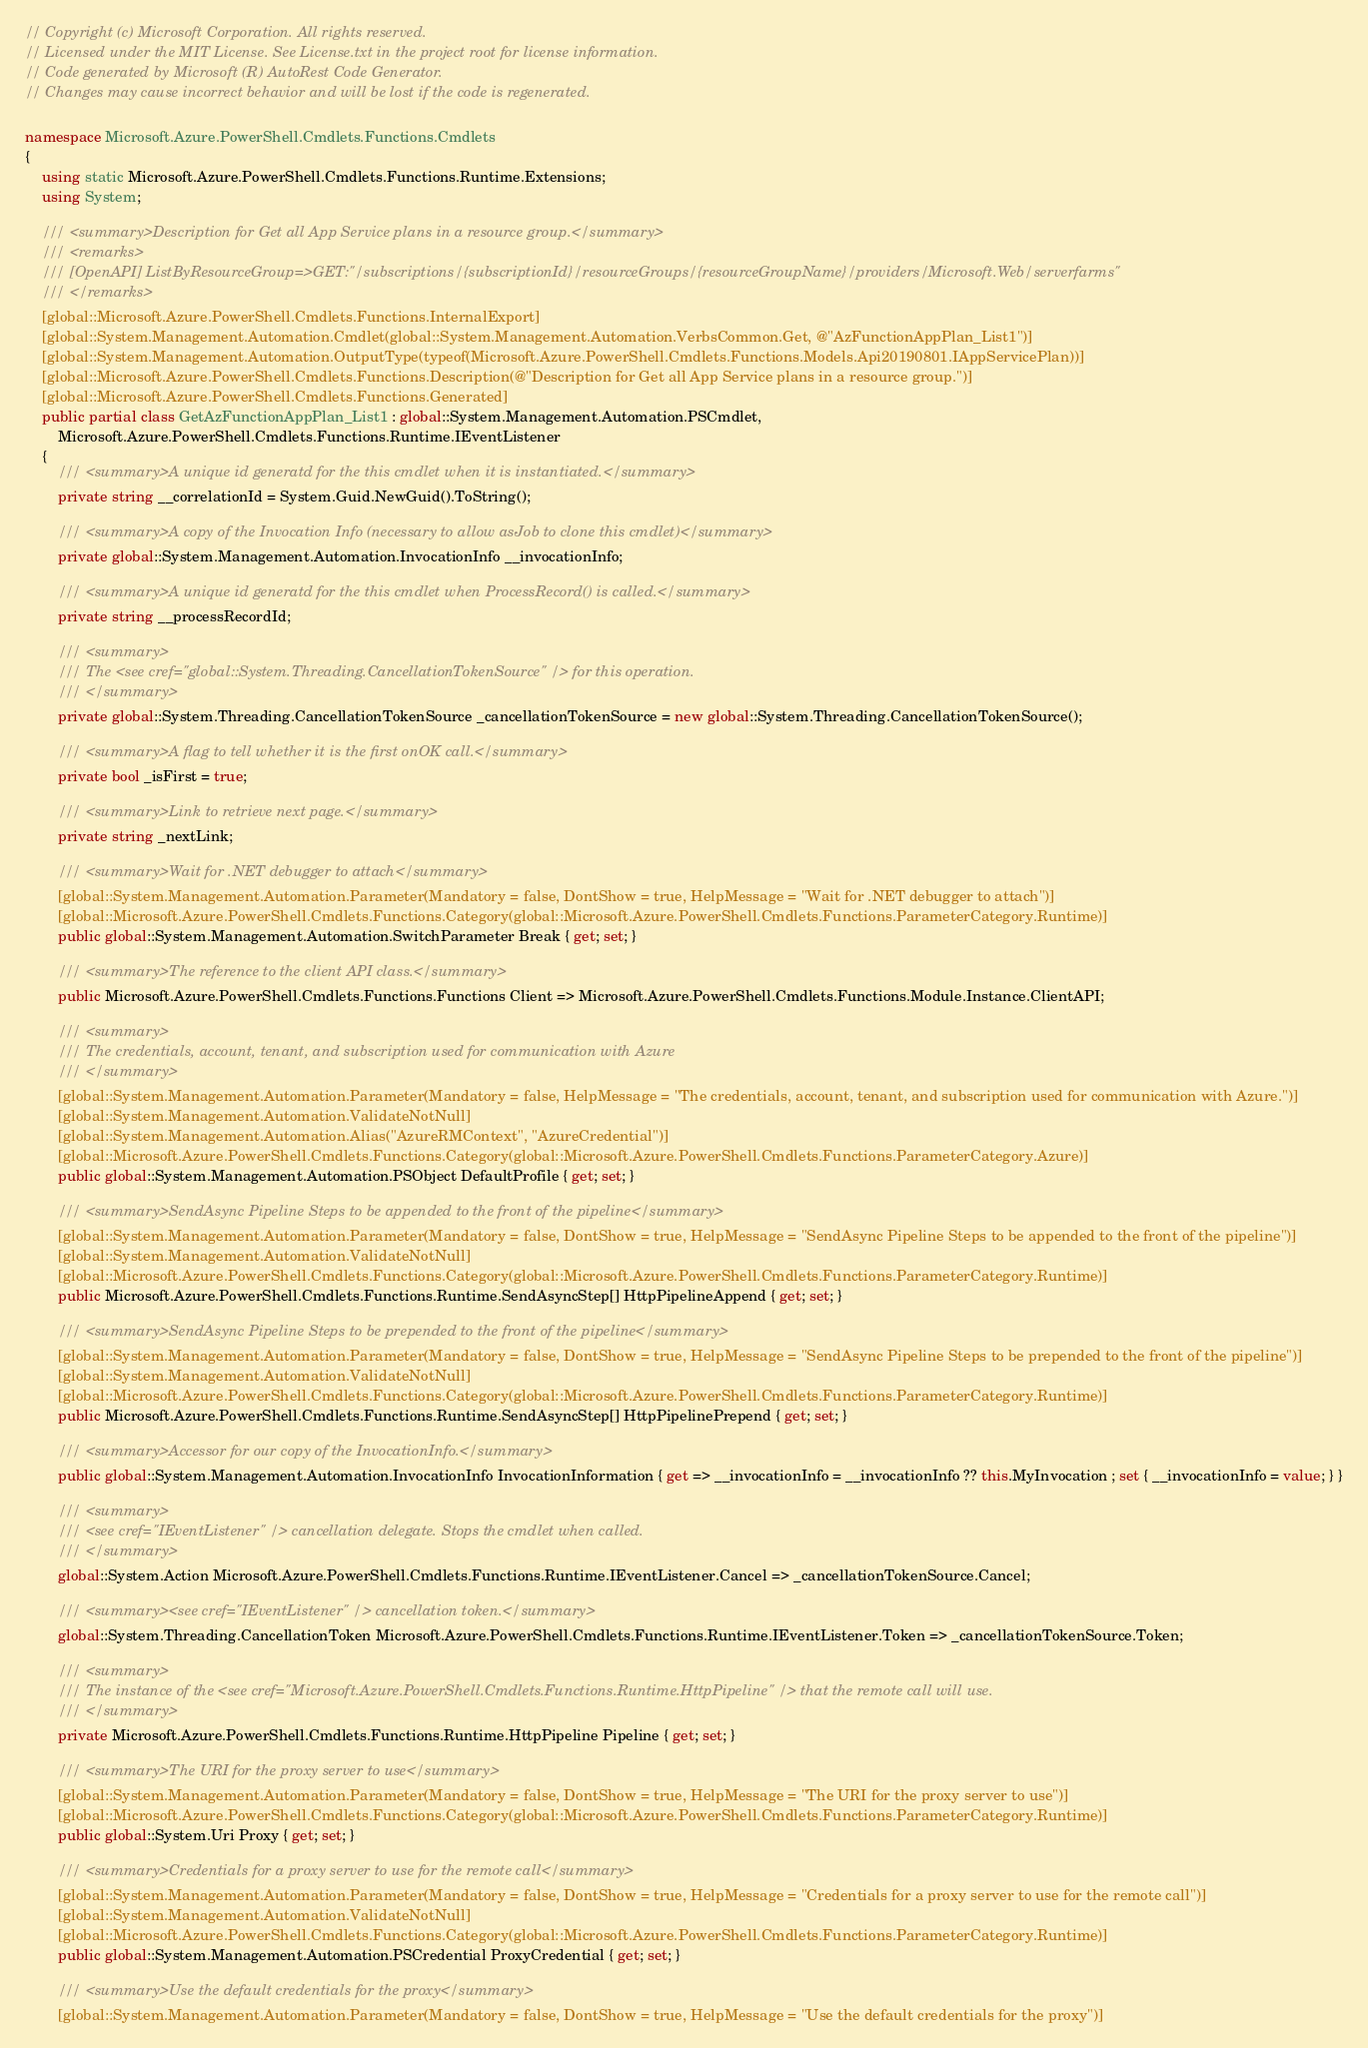<code> <loc_0><loc_0><loc_500><loc_500><_C#_>// Copyright (c) Microsoft Corporation. All rights reserved.
// Licensed under the MIT License. See License.txt in the project root for license information.
// Code generated by Microsoft (R) AutoRest Code Generator.
// Changes may cause incorrect behavior and will be lost if the code is regenerated.

namespace Microsoft.Azure.PowerShell.Cmdlets.Functions.Cmdlets
{
    using static Microsoft.Azure.PowerShell.Cmdlets.Functions.Runtime.Extensions;
    using System;

    /// <summary>Description for Get all App Service plans in a resource group.</summary>
    /// <remarks>
    /// [OpenAPI] ListByResourceGroup=>GET:"/subscriptions/{subscriptionId}/resourceGroups/{resourceGroupName}/providers/Microsoft.Web/serverfarms"
    /// </remarks>
    [global::Microsoft.Azure.PowerShell.Cmdlets.Functions.InternalExport]
    [global::System.Management.Automation.Cmdlet(global::System.Management.Automation.VerbsCommon.Get, @"AzFunctionAppPlan_List1")]
    [global::System.Management.Automation.OutputType(typeof(Microsoft.Azure.PowerShell.Cmdlets.Functions.Models.Api20190801.IAppServicePlan))]
    [global::Microsoft.Azure.PowerShell.Cmdlets.Functions.Description(@"Description for Get all App Service plans in a resource group.")]
    [global::Microsoft.Azure.PowerShell.Cmdlets.Functions.Generated]
    public partial class GetAzFunctionAppPlan_List1 : global::System.Management.Automation.PSCmdlet,
        Microsoft.Azure.PowerShell.Cmdlets.Functions.Runtime.IEventListener
    {
        /// <summary>A unique id generatd for the this cmdlet when it is instantiated.</summary>
        private string __correlationId = System.Guid.NewGuid().ToString();

        /// <summary>A copy of the Invocation Info (necessary to allow asJob to clone this cmdlet)</summary>
        private global::System.Management.Automation.InvocationInfo __invocationInfo;

        /// <summary>A unique id generatd for the this cmdlet when ProcessRecord() is called.</summary>
        private string __processRecordId;

        /// <summary>
        /// The <see cref="global::System.Threading.CancellationTokenSource" /> for this operation.
        /// </summary>
        private global::System.Threading.CancellationTokenSource _cancellationTokenSource = new global::System.Threading.CancellationTokenSource();

        /// <summary>A flag to tell whether it is the first onOK call.</summary>
        private bool _isFirst = true;

        /// <summary>Link to retrieve next page.</summary>
        private string _nextLink;

        /// <summary>Wait for .NET debugger to attach</summary>
        [global::System.Management.Automation.Parameter(Mandatory = false, DontShow = true, HelpMessage = "Wait for .NET debugger to attach")]
        [global::Microsoft.Azure.PowerShell.Cmdlets.Functions.Category(global::Microsoft.Azure.PowerShell.Cmdlets.Functions.ParameterCategory.Runtime)]
        public global::System.Management.Automation.SwitchParameter Break { get; set; }

        /// <summary>The reference to the client API class.</summary>
        public Microsoft.Azure.PowerShell.Cmdlets.Functions.Functions Client => Microsoft.Azure.PowerShell.Cmdlets.Functions.Module.Instance.ClientAPI;

        /// <summary>
        /// The credentials, account, tenant, and subscription used for communication with Azure
        /// </summary>
        [global::System.Management.Automation.Parameter(Mandatory = false, HelpMessage = "The credentials, account, tenant, and subscription used for communication with Azure.")]
        [global::System.Management.Automation.ValidateNotNull]
        [global::System.Management.Automation.Alias("AzureRMContext", "AzureCredential")]
        [global::Microsoft.Azure.PowerShell.Cmdlets.Functions.Category(global::Microsoft.Azure.PowerShell.Cmdlets.Functions.ParameterCategory.Azure)]
        public global::System.Management.Automation.PSObject DefaultProfile { get; set; }

        /// <summary>SendAsync Pipeline Steps to be appended to the front of the pipeline</summary>
        [global::System.Management.Automation.Parameter(Mandatory = false, DontShow = true, HelpMessage = "SendAsync Pipeline Steps to be appended to the front of the pipeline")]
        [global::System.Management.Automation.ValidateNotNull]
        [global::Microsoft.Azure.PowerShell.Cmdlets.Functions.Category(global::Microsoft.Azure.PowerShell.Cmdlets.Functions.ParameterCategory.Runtime)]
        public Microsoft.Azure.PowerShell.Cmdlets.Functions.Runtime.SendAsyncStep[] HttpPipelineAppend { get; set; }

        /// <summary>SendAsync Pipeline Steps to be prepended to the front of the pipeline</summary>
        [global::System.Management.Automation.Parameter(Mandatory = false, DontShow = true, HelpMessage = "SendAsync Pipeline Steps to be prepended to the front of the pipeline")]
        [global::System.Management.Automation.ValidateNotNull]
        [global::Microsoft.Azure.PowerShell.Cmdlets.Functions.Category(global::Microsoft.Azure.PowerShell.Cmdlets.Functions.ParameterCategory.Runtime)]
        public Microsoft.Azure.PowerShell.Cmdlets.Functions.Runtime.SendAsyncStep[] HttpPipelinePrepend { get; set; }

        /// <summary>Accessor for our copy of the InvocationInfo.</summary>
        public global::System.Management.Automation.InvocationInfo InvocationInformation { get => __invocationInfo = __invocationInfo ?? this.MyInvocation ; set { __invocationInfo = value; } }

        /// <summary>
        /// <see cref="IEventListener" /> cancellation delegate. Stops the cmdlet when called.
        /// </summary>
        global::System.Action Microsoft.Azure.PowerShell.Cmdlets.Functions.Runtime.IEventListener.Cancel => _cancellationTokenSource.Cancel;

        /// <summary><see cref="IEventListener" /> cancellation token.</summary>
        global::System.Threading.CancellationToken Microsoft.Azure.PowerShell.Cmdlets.Functions.Runtime.IEventListener.Token => _cancellationTokenSource.Token;

        /// <summary>
        /// The instance of the <see cref="Microsoft.Azure.PowerShell.Cmdlets.Functions.Runtime.HttpPipeline" /> that the remote call will use.
        /// </summary>
        private Microsoft.Azure.PowerShell.Cmdlets.Functions.Runtime.HttpPipeline Pipeline { get; set; }

        /// <summary>The URI for the proxy server to use</summary>
        [global::System.Management.Automation.Parameter(Mandatory = false, DontShow = true, HelpMessage = "The URI for the proxy server to use")]
        [global::Microsoft.Azure.PowerShell.Cmdlets.Functions.Category(global::Microsoft.Azure.PowerShell.Cmdlets.Functions.ParameterCategory.Runtime)]
        public global::System.Uri Proxy { get; set; }

        /// <summary>Credentials for a proxy server to use for the remote call</summary>
        [global::System.Management.Automation.Parameter(Mandatory = false, DontShow = true, HelpMessage = "Credentials for a proxy server to use for the remote call")]
        [global::System.Management.Automation.ValidateNotNull]
        [global::Microsoft.Azure.PowerShell.Cmdlets.Functions.Category(global::Microsoft.Azure.PowerShell.Cmdlets.Functions.ParameterCategory.Runtime)]
        public global::System.Management.Automation.PSCredential ProxyCredential { get; set; }

        /// <summary>Use the default credentials for the proxy</summary>
        [global::System.Management.Automation.Parameter(Mandatory = false, DontShow = true, HelpMessage = "Use the default credentials for the proxy")]</code> 